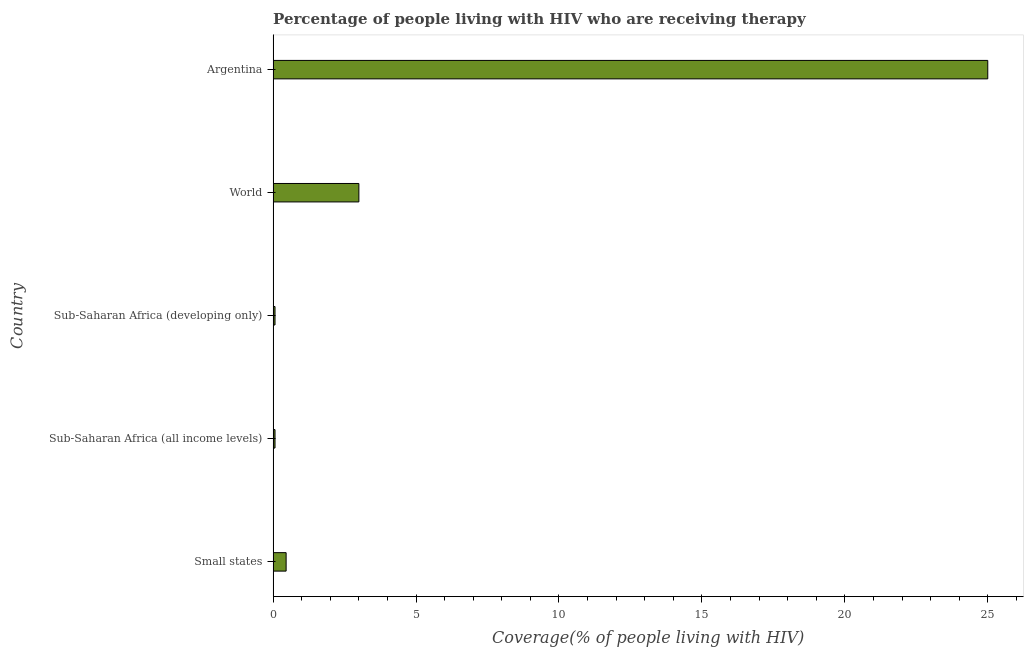Does the graph contain grids?
Your answer should be very brief. No. What is the title of the graph?
Make the answer very short. Percentage of people living with HIV who are receiving therapy. What is the label or title of the X-axis?
Your answer should be very brief. Coverage(% of people living with HIV). What is the label or title of the Y-axis?
Make the answer very short. Country. What is the antiretroviral therapy coverage in Small states?
Offer a very short reply. 0.45. Across all countries, what is the minimum antiretroviral therapy coverage?
Provide a succinct answer. 0.07. In which country was the antiretroviral therapy coverage maximum?
Offer a terse response. Argentina. In which country was the antiretroviral therapy coverage minimum?
Make the answer very short. Sub-Saharan Africa (all income levels). What is the sum of the antiretroviral therapy coverage?
Keep it short and to the point. 28.59. What is the difference between the antiretroviral therapy coverage in Argentina and Sub-Saharan Africa (all income levels)?
Your answer should be compact. 24.93. What is the average antiretroviral therapy coverage per country?
Your answer should be very brief. 5.72. What is the median antiretroviral therapy coverage?
Make the answer very short. 0.45. In how many countries, is the antiretroviral therapy coverage greater than 24 %?
Ensure brevity in your answer.  1. What is the ratio of the antiretroviral therapy coverage in Argentina to that in Sub-Saharan Africa (all income levels)?
Provide a succinct answer. 376.15. What is the difference between the highest and the second highest antiretroviral therapy coverage?
Ensure brevity in your answer.  22. What is the difference between the highest and the lowest antiretroviral therapy coverage?
Offer a terse response. 24.93. What is the difference between two consecutive major ticks on the X-axis?
Your response must be concise. 5. Are the values on the major ticks of X-axis written in scientific E-notation?
Provide a short and direct response. No. What is the Coverage(% of people living with HIV) of Small states?
Your answer should be very brief. 0.45. What is the Coverage(% of people living with HIV) of Sub-Saharan Africa (all income levels)?
Give a very brief answer. 0.07. What is the Coverage(% of people living with HIV) of Sub-Saharan Africa (developing only)?
Give a very brief answer. 0.07. What is the Coverage(% of people living with HIV) of Argentina?
Ensure brevity in your answer.  25. What is the difference between the Coverage(% of people living with HIV) in Small states and Sub-Saharan Africa (all income levels)?
Keep it short and to the point. 0.39. What is the difference between the Coverage(% of people living with HIV) in Small states and Sub-Saharan Africa (developing only)?
Offer a terse response. 0.39. What is the difference between the Coverage(% of people living with HIV) in Small states and World?
Offer a terse response. -2.55. What is the difference between the Coverage(% of people living with HIV) in Small states and Argentina?
Keep it short and to the point. -24.55. What is the difference between the Coverage(% of people living with HIV) in Sub-Saharan Africa (all income levels) and Sub-Saharan Africa (developing only)?
Ensure brevity in your answer.  -2e-5. What is the difference between the Coverage(% of people living with HIV) in Sub-Saharan Africa (all income levels) and World?
Keep it short and to the point. -2.93. What is the difference between the Coverage(% of people living with HIV) in Sub-Saharan Africa (all income levels) and Argentina?
Offer a very short reply. -24.93. What is the difference between the Coverage(% of people living with HIV) in Sub-Saharan Africa (developing only) and World?
Your response must be concise. -2.93. What is the difference between the Coverage(% of people living with HIV) in Sub-Saharan Africa (developing only) and Argentina?
Ensure brevity in your answer.  -24.93. What is the ratio of the Coverage(% of people living with HIV) in Small states to that in Sub-Saharan Africa (all income levels)?
Provide a short and direct response. 6.84. What is the ratio of the Coverage(% of people living with HIV) in Small states to that in Sub-Saharan Africa (developing only)?
Provide a short and direct response. 6.84. What is the ratio of the Coverage(% of people living with HIV) in Small states to that in World?
Your answer should be compact. 0.15. What is the ratio of the Coverage(% of people living with HIV) in Small states to that in Argentina?
Provide a succinct answer. 0.02. What is the ratio of the Coverage(% of people living with HIV) in Sub-Saharan Africa (all income levels) to that in World?
Make the answer very short. 0.02. What is the ratio of the Coverage(% of people living with HIV) in Sub-Saharan Africa (all income levels) to that in Argentina?
Provide a short and direct response. 0. What is the ratio of the Coverage(% of people living with HIV) in Sub-Saharan Africa (developing only) to that in World?
Keep it short and to the point. 0.02. What is the ratio of the Coverage(% of people living with HIV) in Sub-Saharan Africa (developing only) to that in Argentina?
Your response must be concise. 0. What is the ratio of the Coverage(% of people living with HIV) in World to that in Argentina?
Make the answer very short. 0.12. 